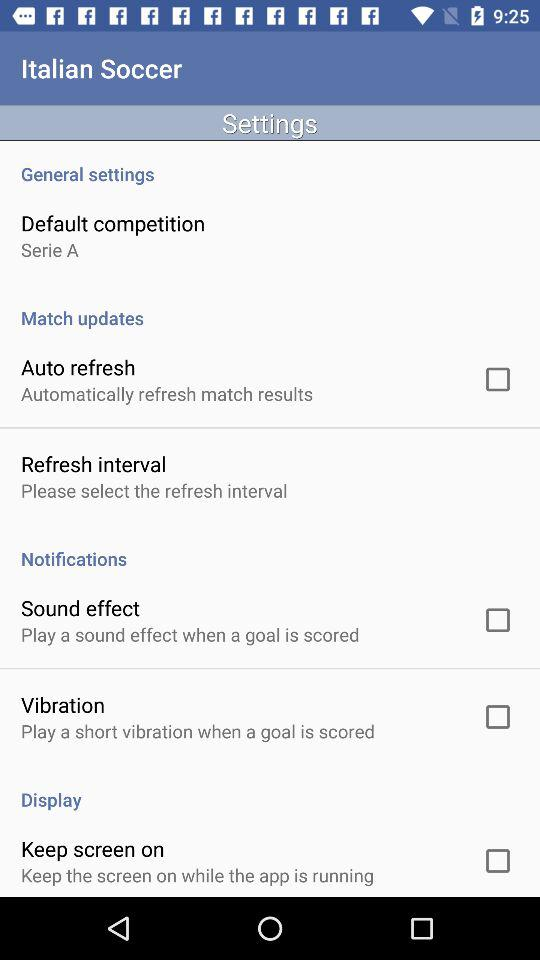What is the status of the "Auto refresh"? The status is "off". 